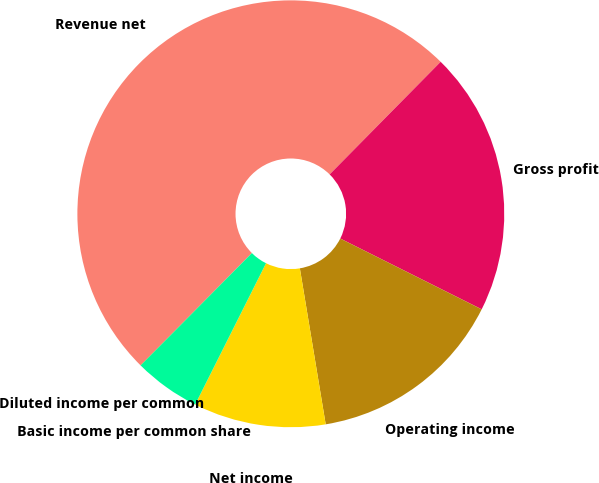<chart> <loc_0><loc_0><loc_500><loc_500><pie_chart><fcel>Revenue net<fcel>Gross profit<fcel>Operating income<fcel>Net income<fcel>Basic income per common share<fcel>Diluted income per common<nl><fcel>49.95%<fcel>20.0%<fcel>15.0%<fcel>10.01%<fcel>5.02%<fcel>0.02%<nl></chart> 